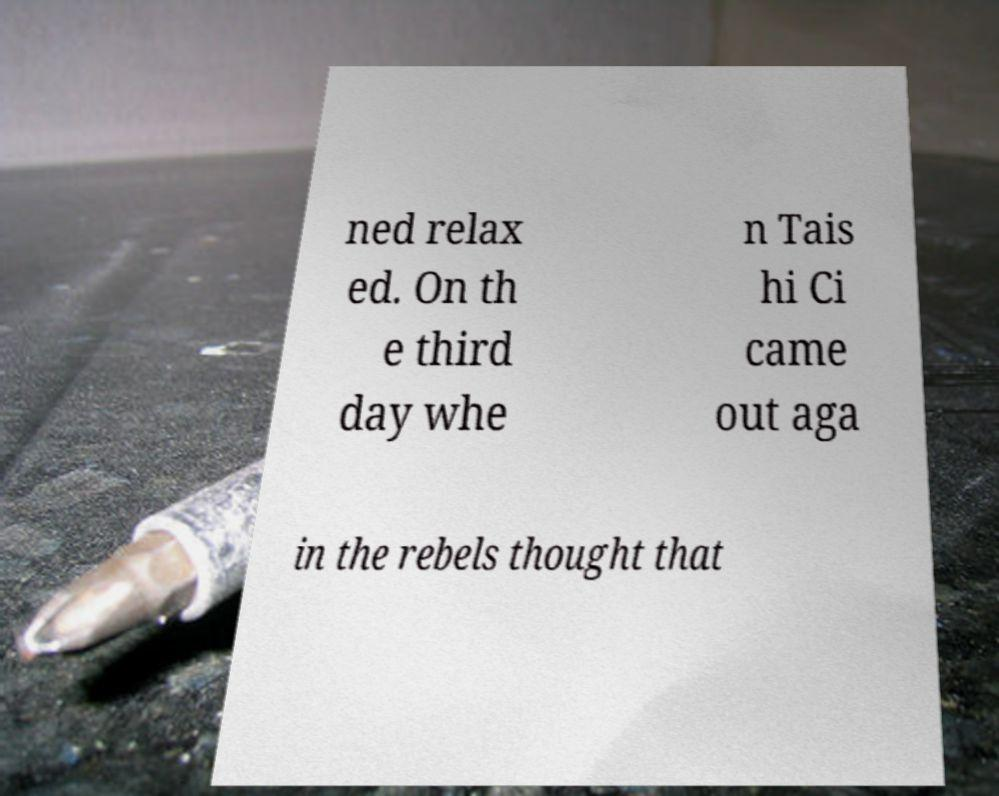Could you extract and type out the text from this image? ned relax ed. On th e third day whe n Tais hi Ci came out aga in the rebels thought that 